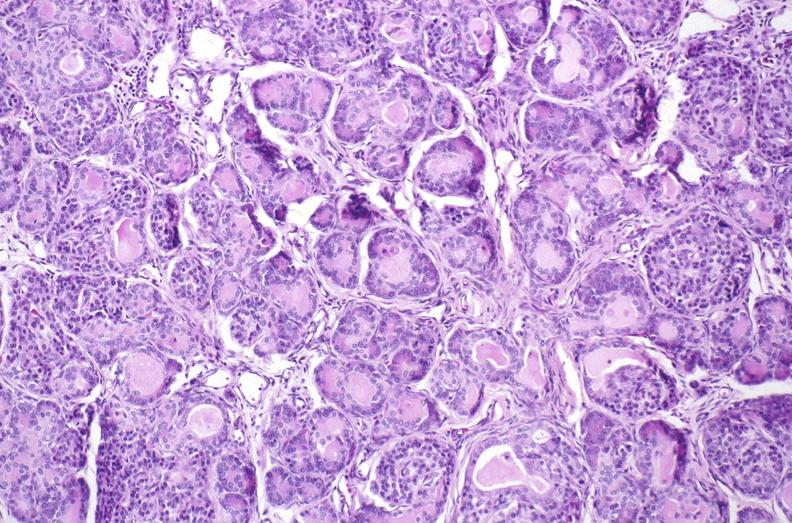does testicle show cystic fibrosis?
Answer the question using a single word or phrase. No 